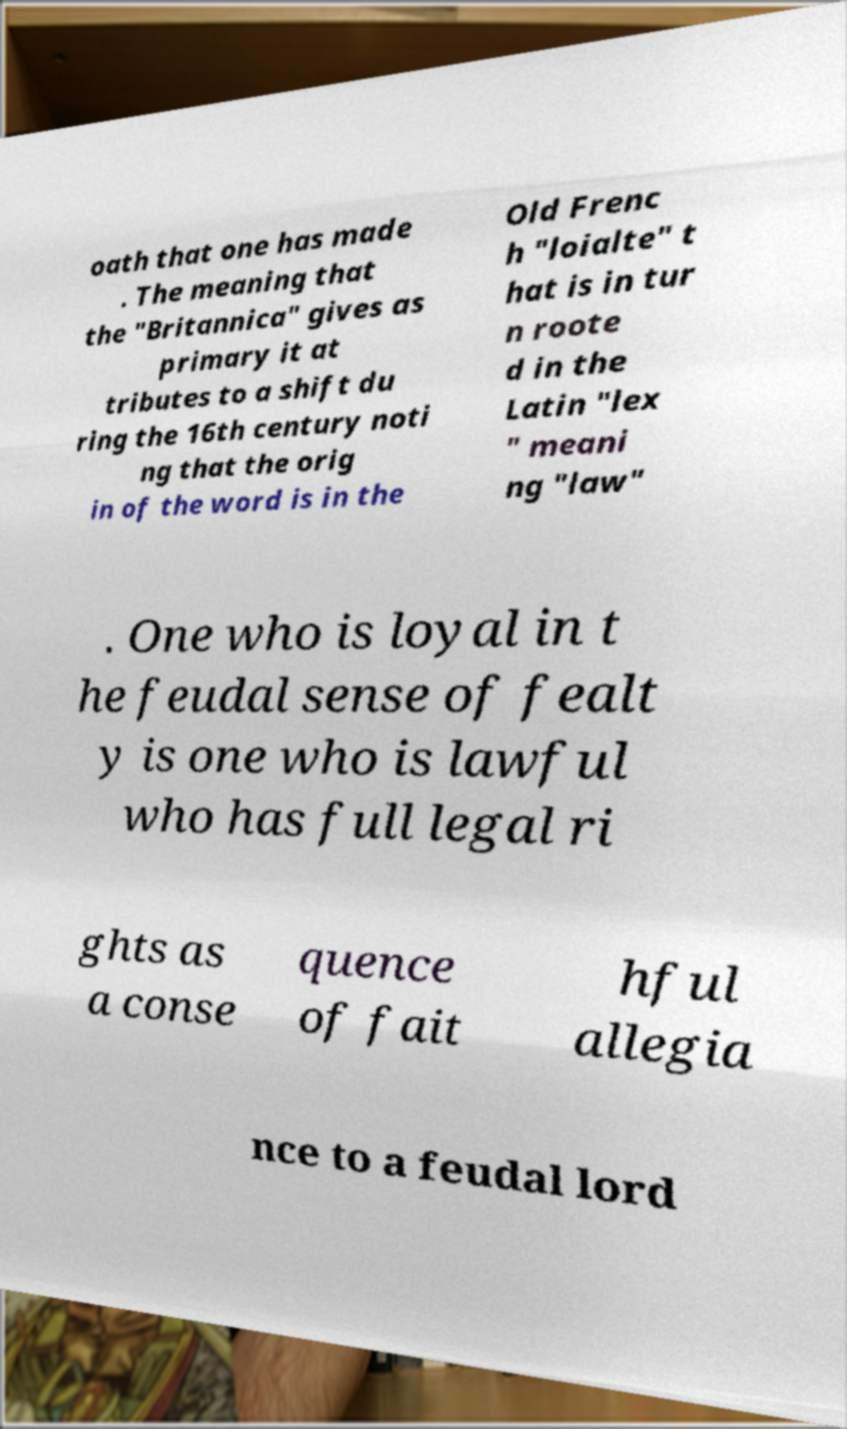Can you read and provide the text displayed in the image?This photo seems to have some interesting text. Can you extract and type it out for me? oath that one has made . The meaning that the "Britannica" gives as primary it at tributes to a shift du ring the 16th century noti ng that the orig in of the word is in the Old Frenc h "loialte" t hat is in tur n roote d in the Latin "lex " meani ng "law" . One who is loyal in t he feudal sense of fealt y is one who is lawful who has full legal ri ghts as a conse quence of fait hful allegia nce to a feudal lord 